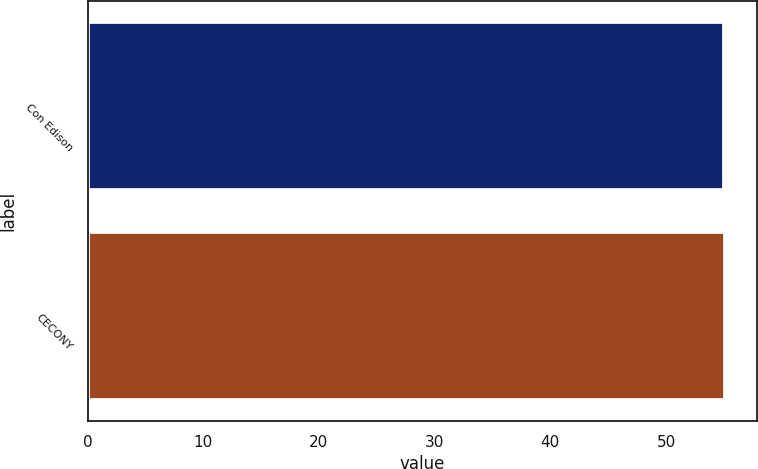Convert chart. <chart><loc_0><loc_0><loc_500><loc_500><bar_chart><fcel>Con Edison<fcel>CECONY<nl><fcel>55<fcel>55.1<nl></chart> 